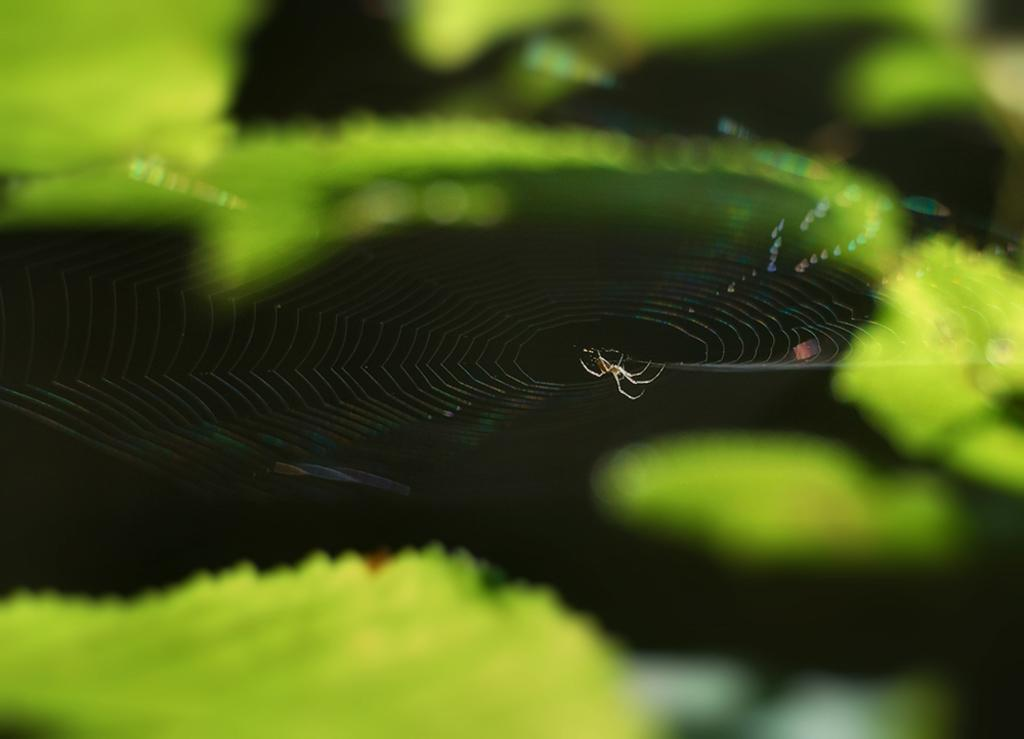What is the main subject of the image? There is a spider in the image. What is associated with the spider in the image? There is a spider web in the image. What colors can be seen in the background of the image? The background of the image is green and black in color. What type of guitar is being played in the image? There is no guitar present in the image; it features a spider and a spider web. How many rabbits can be seen in the image? There are no rabbits present in the image; it features a spider and a spider web. 